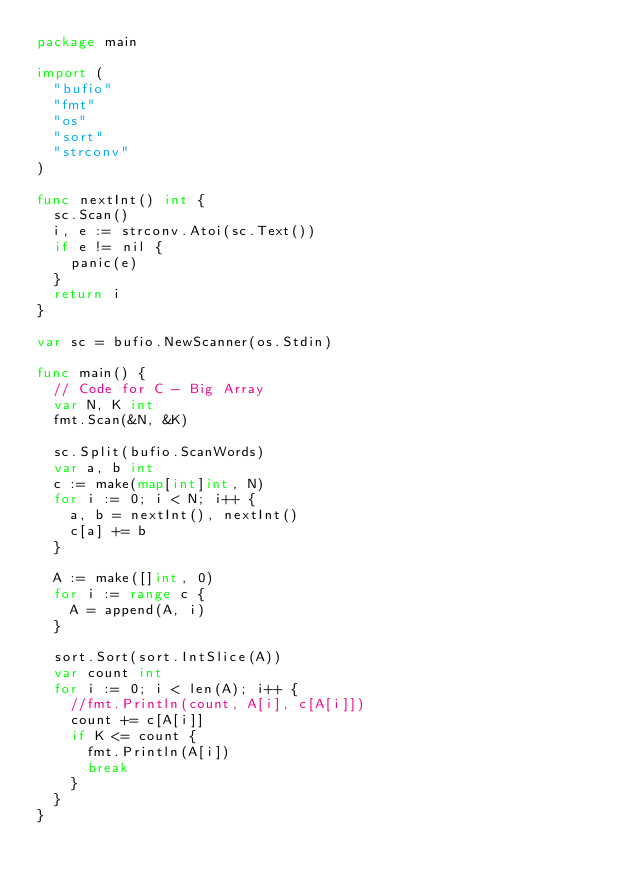Convert code to text. <code><loc_0><loc_0><loc_500><loc_500><_Go_>package main

import (
	"bufio"
	"fmt"
	"os"
	"sort"
	"strconv"
)

func nextInt() int {
	sc.Scan()
	i, e := strconv.Atoi(sc.Text())
	if e != nil {
		panic(e)
	}
	return i
}

var sc = bufio.NewScanner(os.Stdin)

func main() {
	// Code for C - Big Array
	var N, K int
	fmt.Scan(&N, &K)

	sc.Split(bufio.ScanWords)
	var a, b int
	c := make(map[int]int, N)
	for i := 0; i < N; i++ {
		a, b = nextInt(), nextInt()
		c[a] += b
	}

	A := make([]int, 0)
	for i := range c {
		A = append(A, i)
	}

	sort.Sort(sort.IntSlice(A))
	var count int
	for i := 0; i < len(A); i++ {
		//fmt.Println(count, A[i], c[A[i]])
		count += c[A[i]]
		if K <= count {
			fmt.Println(A[i])
			break
		}
	}
}
</code> 